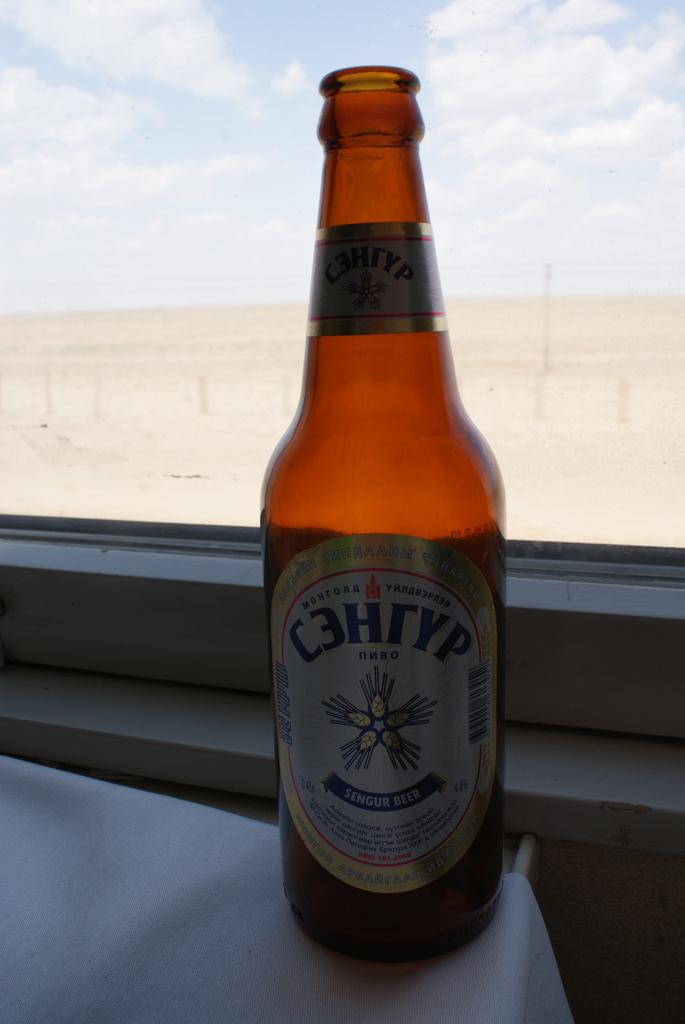Provide a one-sentence caption for the provided image. An empty bottle of sengur beer sitting on a windowsill. 